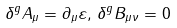Convert formula to latex. <formula><loc_0><loc_0><loc_500><loc_500>\delta ^ { g } A _ { \mu } = \partial _ { \mu } \varepsilon , \, \delta ^ { g } B _ { \mu \nu } = 0</formula> 